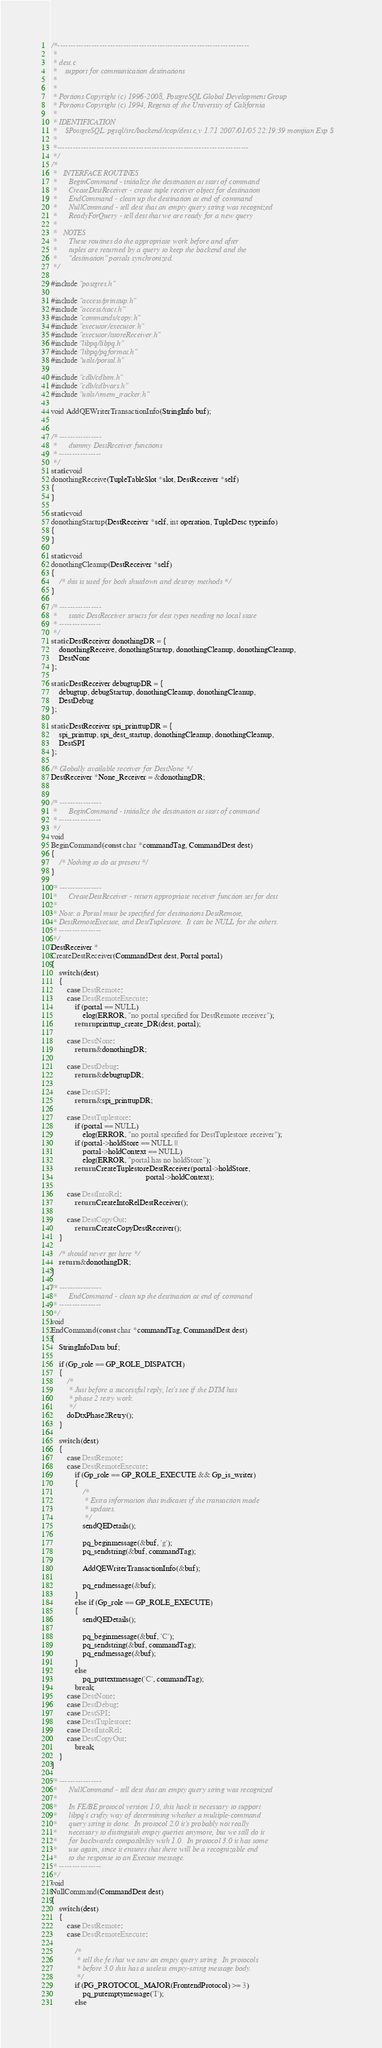Convert code to text. <code><loc_0><loc_0><loc_500><loc_500><_C_>/*-------------------------------------------------------------------------
 *
 * dest.c
 *	  support for communication destinations
 *
 *
 * Portions Copyright (c) 1996-2008, PostgreSQL Global Development Group
 * Portions Copyright (c) 1994, Regents of the University of California
 *
 * IDENTIFICATION
 *	  $PostgreSQL: pgsql/src/backend/tcop/dest.c,v 1.71 2007/01/05 22:19:39 momjian Exp $
 *
 *-------------------------------------------------------------------------
 */
/*
 *	 INTERFACE ROUTINES
 *		BeginCommand - initialize the destination at start of command
 *		CreateDestReceiver - create tuple receiver object for destination
 *		EndCommand - clean up the destination at end of command
 *		NullCommand - tell dest that an empty query string was recognized
 *		ReadyForQuery - tell dest that we are ready for a new query
 *
 *	 NOTES
 *		These routines do the appropriate work before and after
 *		tuples are returned by a query to keep the backend and the
 *		"destination" portals synchronized.
 */

#include "postgres.h"

#include "access/printtup.h"
#include "access/xact.h"
#include "commands/copy.h"
#include "executor/executor.h"
#include "executor/tstoreReceiver.h"
#include "libpq/libpq.h"
#include "libpq/pqformat.h"
#include "utils/portal.h"

#include "cdb/cdbtm.h"
#include "cdb/cdbvars.h"
#include "utils/vmem_tracker.h"

void AddQEWriterTransactionInfo(StringInfo buf);


/* ----------------
 *		dummy DestReceiver functions
 * ----------------
 */
static void
donothingReceive(TupleTableSlot *slot, DestReceiver *self)
{
}

static void
donothingStartup(DestReceiver *self, int operation, TupleDesc typeinfo)
{
}

static void
donothingCleanup(DestReceiver *self)
{
	/* this is used for both shutdown and destroy methods */
}

/* ----------------
 *		static DestReceiver structs for dest types needing no local state
 * ----------------
 */
static DestReceiver donothingDR = {
	donothingReceive, donothingStartup, donothingCleanup, donothingCleanup,
	DestNone
};

static DestReceiver debugtupDR = {
	debugtup, debugStartup, donothingCleanup, donothingCleanup,
	DestDebug
};

static DestReceiver spi_printtupDR = {
	spi_printtup, spi_dest_startup, donothingCleanup, donothingCleanup,
	DestSPI
};

/* Globally available receiver for DestNone */
DestReceiver *None_Receiver = &donothingDR;


/* ----------------
 *		BeginCommand - initialize the destination at start of command
 * ----------------
 */
void
BeginCommand(const char *commandTag, CommandDest dest)
{
	/* Nothing to do at present */
}

/* ----------------
 *		CreateDestReceiver - return appropriate receiver function set for dest
 *
 * Note: a Portal must be specified for destinations DestRemote,
 * DestRemoteExecute, and DestTuplestore.  It can be NULL for the others.
 * ----------------
 */
DestReceiver *
CreateDestReceiver(CommandDest dest, Portal portal)
{
	switch (dest)
	{
		case DestRemote:
		case DestRemoteExecute:
			if (portal == NULL)
				elog(ERROR, "no portal specified for DestRemote receiver");
			return printtup_create_DR(dest, portal);

		case DestNone:
			return &donothingDR;

		case DestDebug:
			return &debugtupDR;

		case DestSPI:
			return &spi_printtupDR;

		case DestTuplestore:
			if (portal == NULL)
				elog(ERROR, "no portal specified for DestTuplestore receiver");
			if (portal->holdStore == NULL ||
				portal->holdContext == NULL)
				elog(ERROR, "portal has no holdStore");
			return CreateTuplestoreDestReceiver(portal->holdStore,
												portal->holdContext);

		case DestIntoRel:
			return CreateIntoRelDestReceiver();

		case DestCopyOut:
			return CreateCopyDestReceiver();
	}

	/* should never get here */
	return &donothingDR;
}

/* ----------------
 *		EndCommand - clean up the destination at end of command
 * ----------------
 */
void
EndCommand(const char *commandTag, CommandDest dest)
{
	StringInfoData buf;

	if (Gp_role == GP_ROLE_DISPATCH)
	{
		/*
		 * Just before a successful reply, let's see if the DTM has
		 * phase 2 retry work.
		 */
		doDtxPhase2Retry();
	}
	
	switch (dest)
	{
		case DestRemote:
		case DestRemoteExecute:
			if (Gp_role == GP_ROLE_EXECUTE && Gp_is_writer)
			{
				/*
				 * Extra information that indicates if the transaction made
				 * updates.
				 */
				sendQEDetails();

				pq_beginmessage(&buf, 'g');
				pq_sendstring(&buf, commandTag);

				AddQEWriterTransactionInfo(&buf);

				pq_endmessage(&buf);
			}
			else if (Gp_role == GP_ROLE_EXECUTE)
			{
				sendQEDetails();

				pq_beginmessage(&buf, 'C');
				pq_sendstring(&buf, commandTag);
				pq_endmessage(&buf);
			}
			else
				pq_puttextmessage('C', commandTag);
			break;
		case DestNone:
		case DestDebug:
		case DestSPI:
		case DestTuplestore:
		case DestIntoRel:
		case DestCopyOut:
			break;
	}
}

/* ----------------
 *		NullCommand - tell dest that an empty query string was recognized
 *
 *		In FE/BE protocol version 1.0, this hack is necessary to support
 *		libpq's crufty way of determining whether a multiple-command
 *		query string is done.  In protocol 2.0 it's probably not really
 *		necessary to distinguish empty queries anymore, but we still do it
 *		for backwards compatibility with 1.0.  In protocol 3.0 it has some
 *		use again, since it ensures that there will be a recognizable end
 *		to the response to an Execute message.
 * ----------------
 */
void
NullCommand(CommandDest dest)
{
	switch (dest)
	{
		case DestRemote:
		case DestRemoteExecute:

			/*
			 * tell the fe that we saw an empty query string.  In protocols
			 * before 3.0 this has a useless empty-string message body.
			 */
			if (PG_PROTOCOL_MAJOR(FrontendProtocol) >= 3)
				pq_putemptymessage('I');
			else</code> 